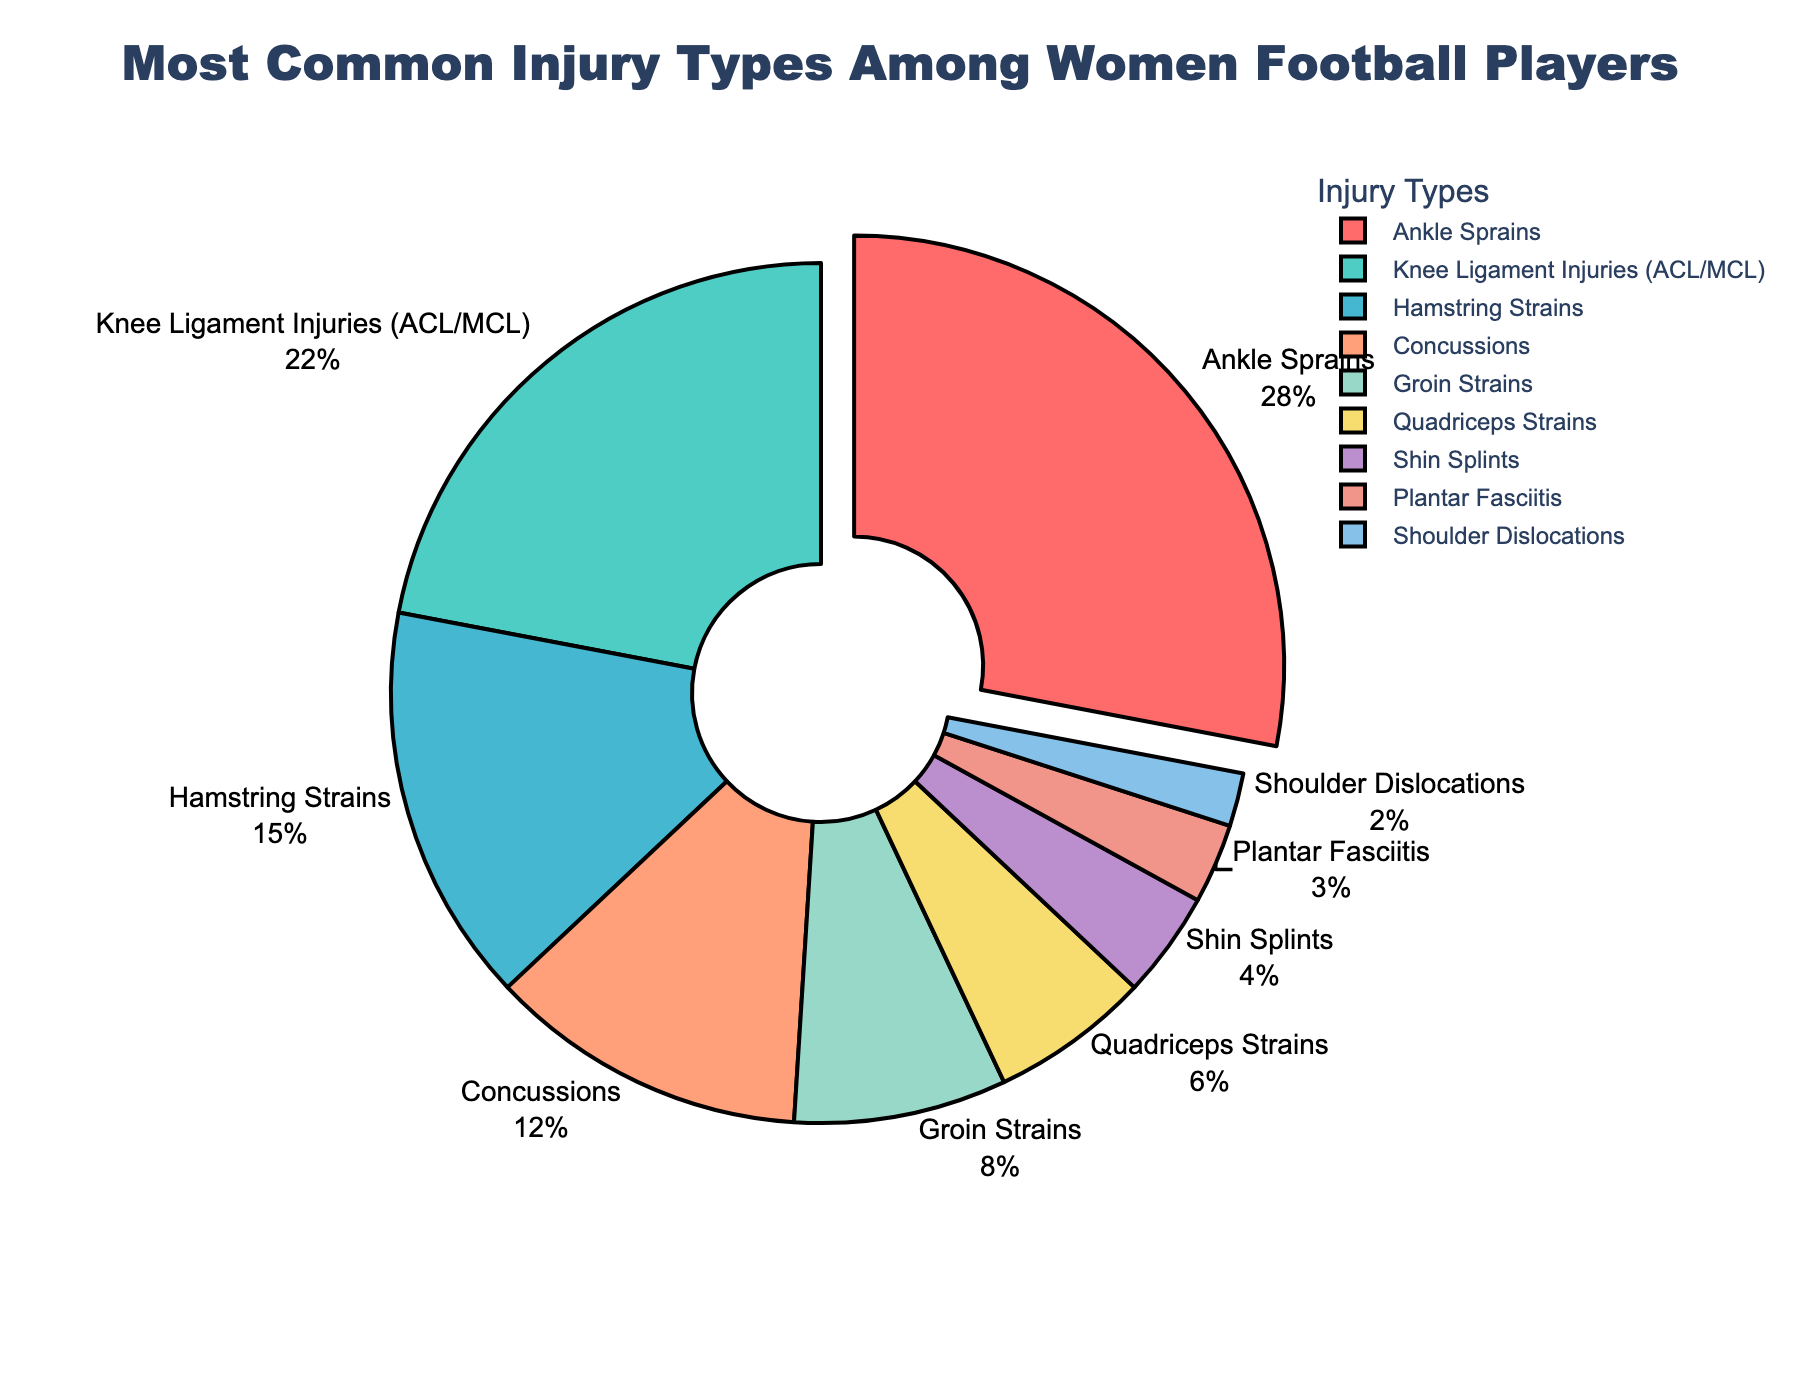What is the most common injury type among women football players? The most common injury type can be identified by looking at the largest segment in the pie chart which is labeled with a percentage. The segment with the highest percentage is the most common injury.
Answer: Ankle Sprains What percentage of injuries are related to knee ligament injuries? Locate the segment of the pie chart labeled “Knee Ligament Injuries (ACL/MCL)” and observe the percentage value associated with it.
Answer: 22% What is the combined percentage of hamstring strains and groin strains? Sum the percentages of the segments labeled “Hamstring Strains” and “Groin Strains” from the pie chart. Hamstring Strains are 15%, and Groin Strains are 8%. Therefore, the combined percentage is 15% + 8%.
Answer: 23% Which injury type is less common, shin splints or quadriceps strains? Compare the segments labeled “Shin Splints” and “Quadriceps Strains” on the pie chart. Observe their percentage values to see which one is smaller.
Answer: Shin Splints How much more common are ankle sprains compared to quadriceps strains? Find the percentage values for ankle sprains and quadriceps strains. Subtract the percentage of quadriceps strains from the percentage of ankle sprains to determine how much more common ankle sprains are. Ankle Sprains are 28%, and Quadriceps Strains are 6%, so the difference is 28% - 6%.
Answer: 22% Combine the percentages of the three most common injury types. Identify the three largest segments in the pie chart and sum their percentages. The three most common injury types are Ankle Sprains (28%), Knee Ligament Injuries (22%), and Hamstring Strains (15%). Therefore, the combined percentage is 28% + 22% + 15%.
Answer: 65% What injury type is represented by the smallest segment in the chart? Look for the segment in the pie chart with the smallest percentage. This is the smallest segment, and the label next to it will indicate the injury type.
Answer: Shoulder Dislocations 